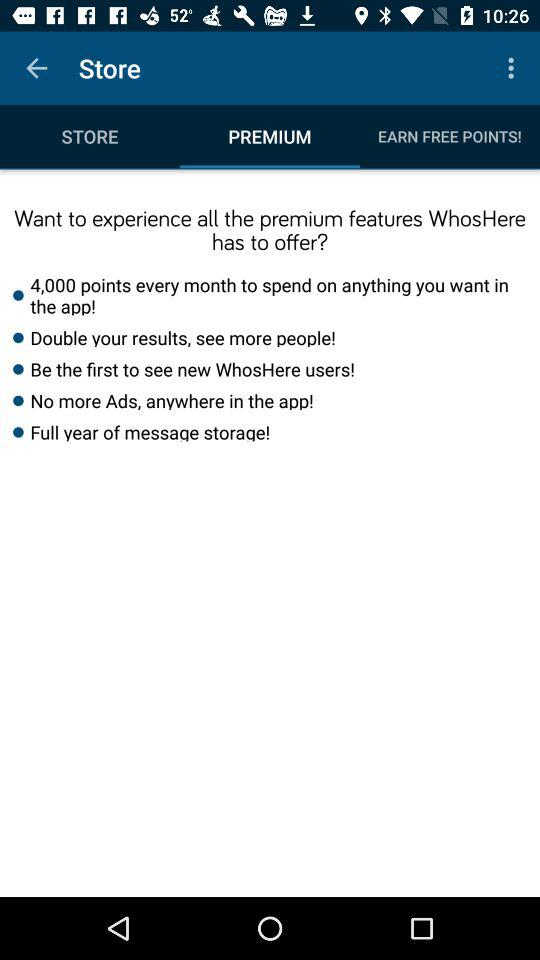What is the selected tab? The selected tab is "PREMIUM". 